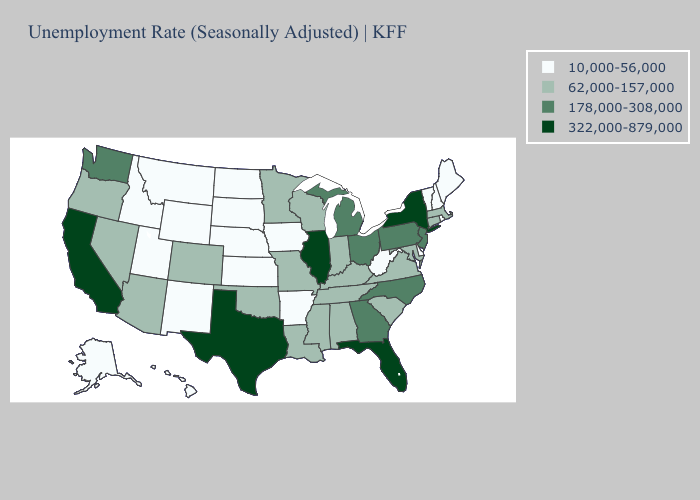Is the legend a continuous bar?
Answer briefly. No. Name the states that have a value in the range 322,000-879,000?
Be succinct. California, Florida, Illinois, New York, Texas. What is the value of South Dakota?
Give a very brief answer. 10,000-56,000. Does Virginia have a lower value than Maine?
Give a very brief answer. No. What is the lowest value in states that border Louisiana?
Give a very brief answer. 10,000-56,000. Which states have the lowest value in the Northeast?
Short answer required. Maine, New Hampshire, Rhode Island, Vermont. What is the highest value in states that border New Jersey?
Answer briefly. 322,000-879,000. What is the value of Michigan?
Write a very short answer. 178,000-308,000. What is the value of Connecticut?
Write a very short answer. 62,000-157,000. Name the states that have a value in the range 178,000-308,000?
Short answer required. Georgia, Michigan, New Jersey, North Carolina, Ohio, Pennsylvania, Washington. Does California have the highest value in the West?
Short answer required. Yes. Name the states that have a value in the range 322,000-879,000?
Write a very short answer. California, Florida, Illinois, New York, Texas. Among the states that border Maryland , which have the highest value?
Write a very short answer. Pennsylvania. Name the states that have a value in the range 322,000-879,000?
Answer briefly. California, Florida, Illinois, New York, Texas. How many symbols are there in the legend?
Keep it brief. 4. 